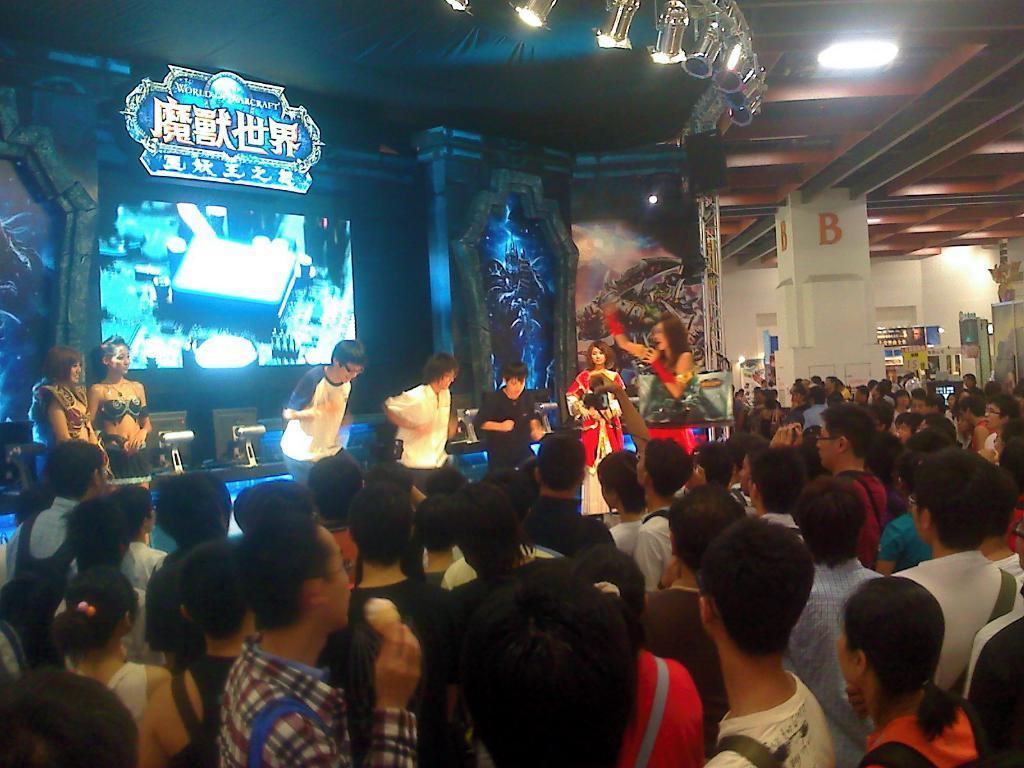How would you summarize this image in a sentence or two? In this image we can see a group of people standing on the stage. In that a woman is holding a mic. We can also see the display screen, a signboard and some lights to a roof. On the bottom of the image we can see a group of people standing. In that some are holding the cameras and mobile phones. We can also see a man holding an ice cream. 